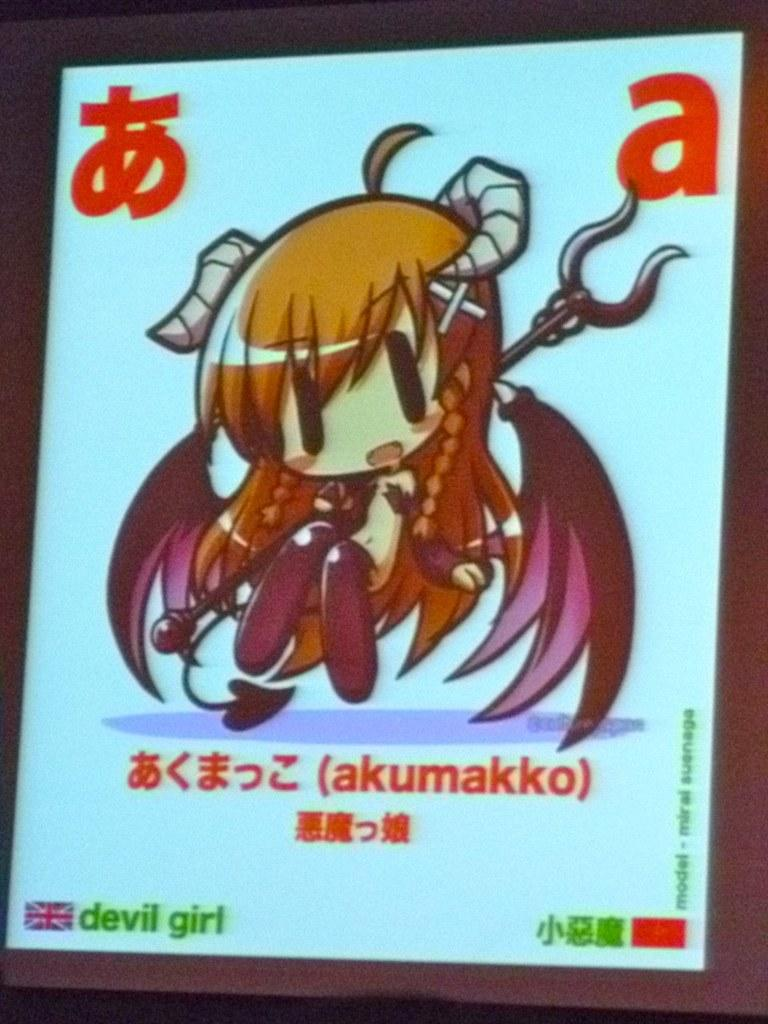<image>
Provide a brief description of the given image. A blue sign with a cartoon drawing on it and an A top right. 